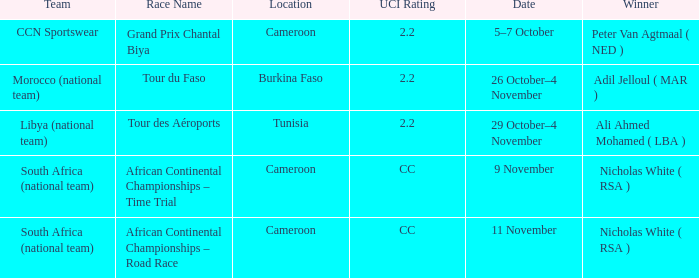Who is the winner of the race in Burkina Faso? Adil Jelloul ( MAR ). 